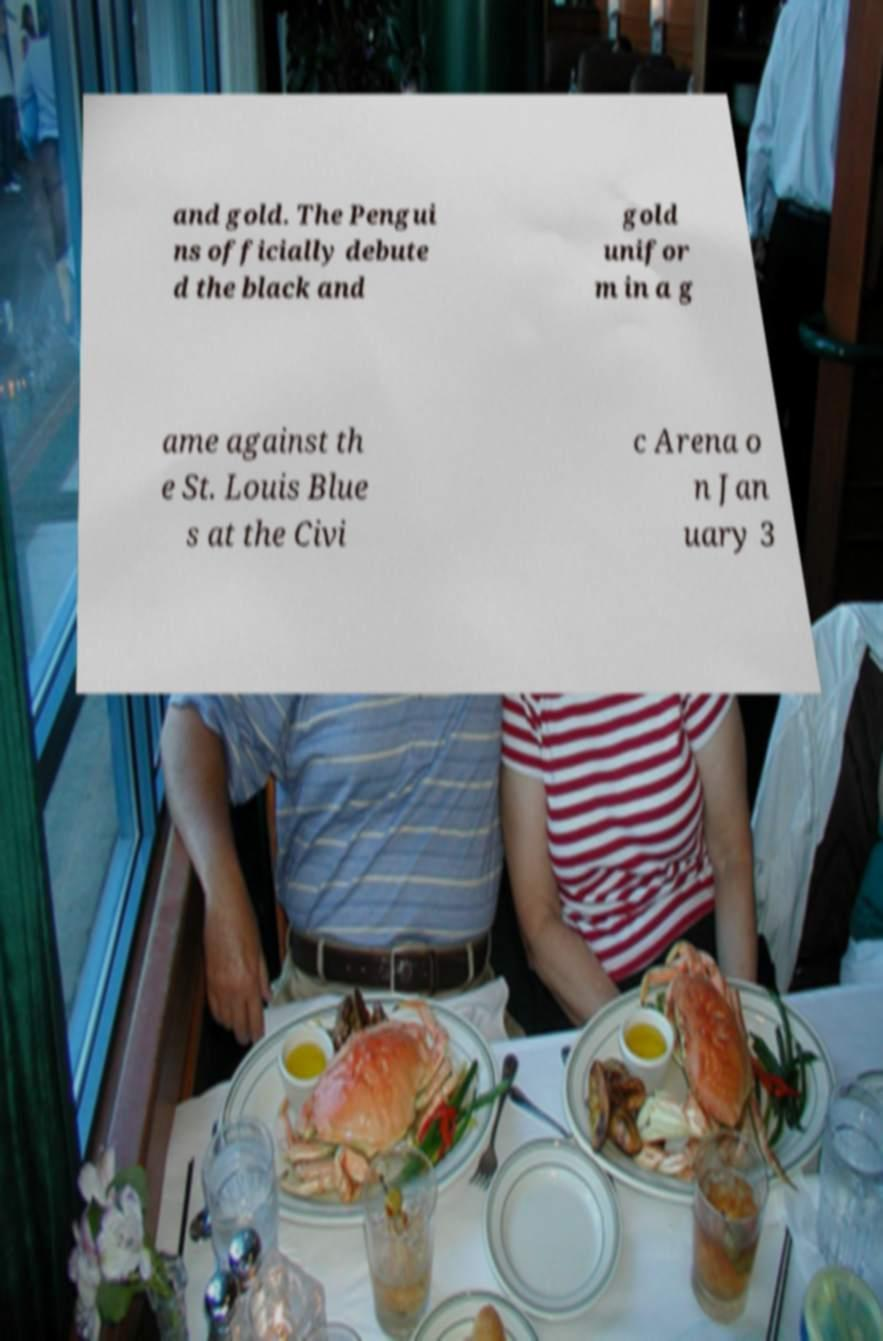Can you accurately transcribe the text from the provided image for me? and gold. The Pengui ns officially debute d the black and gold unifor m in a g ame against th e St. Louis Blue s at the Civi c Arena o n Jan uary 3 